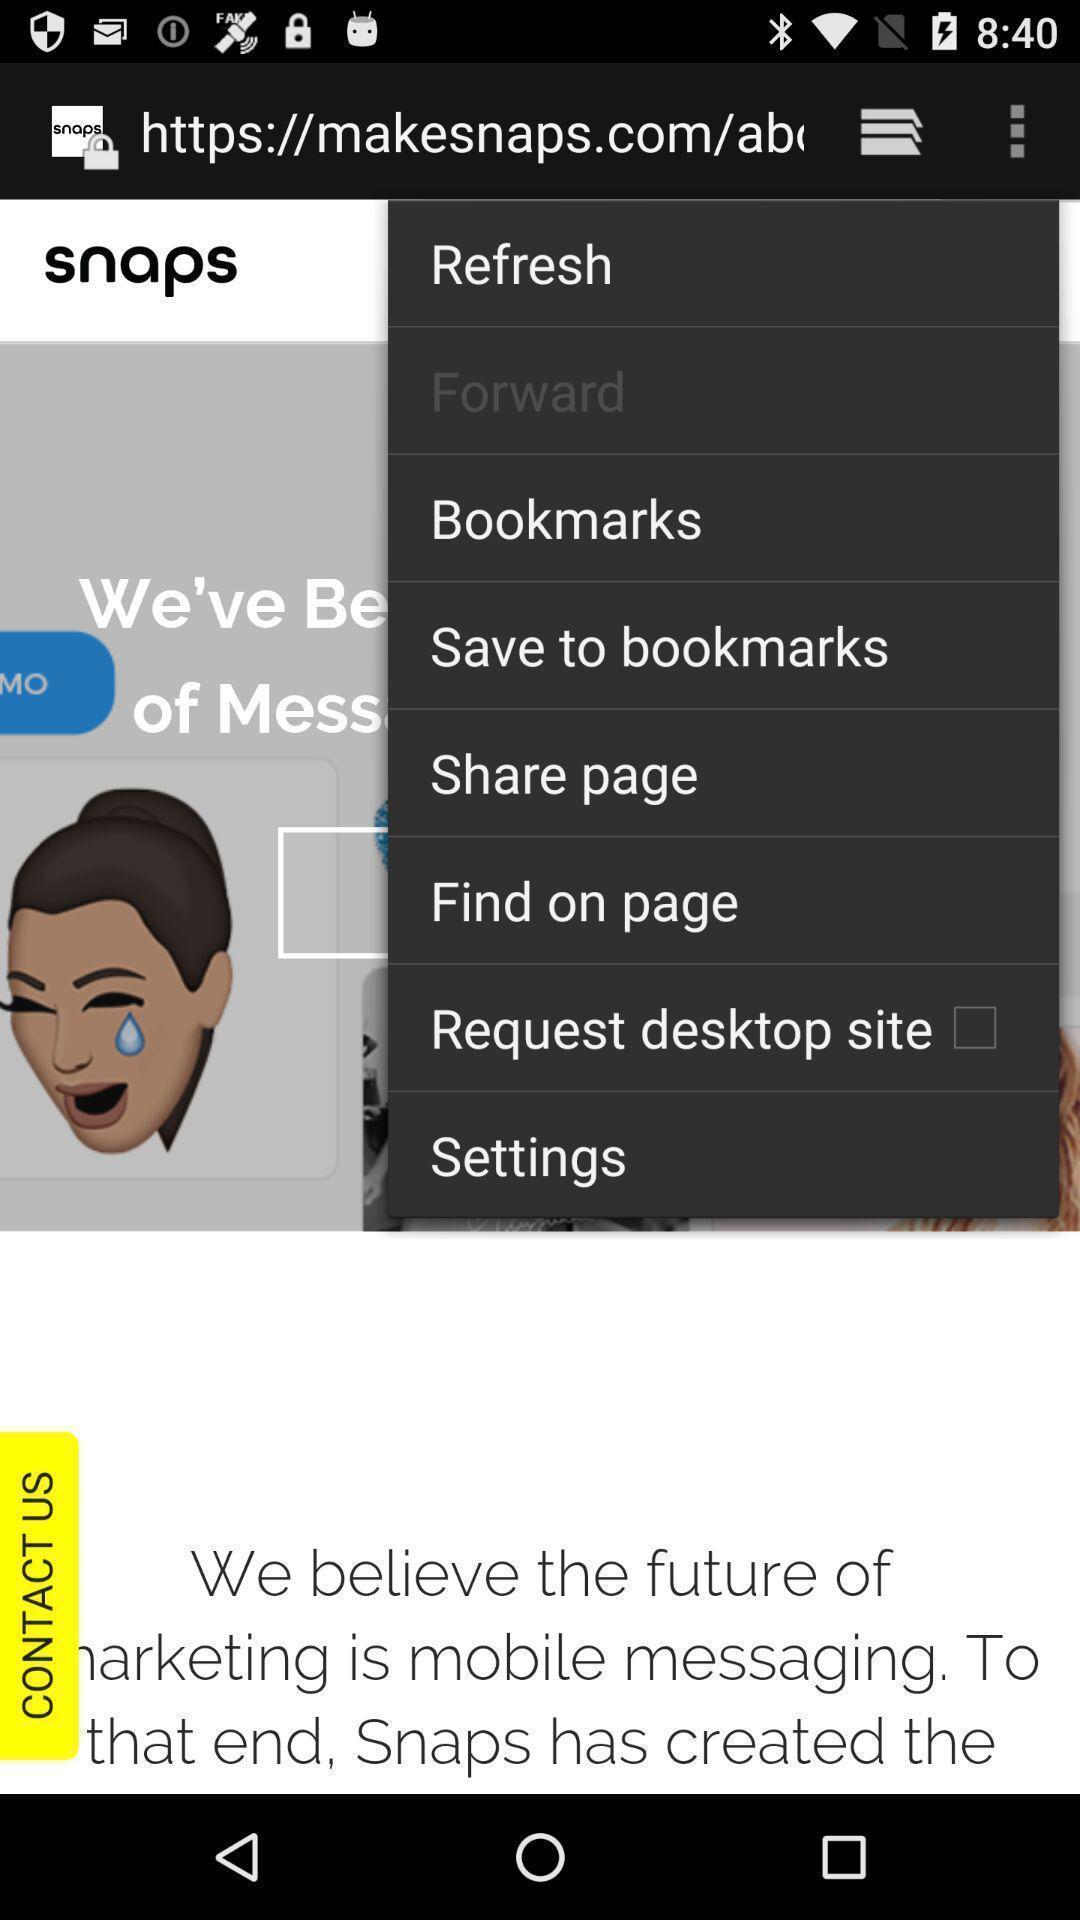Explain the elements present in this screenshot. Pop up showing list of options. 